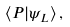Convert formula to latex. <formula><loc_0><loc_0><loc_500><loc_500>\langle P | \psi _ { L } \rangle \, ,</formula> 